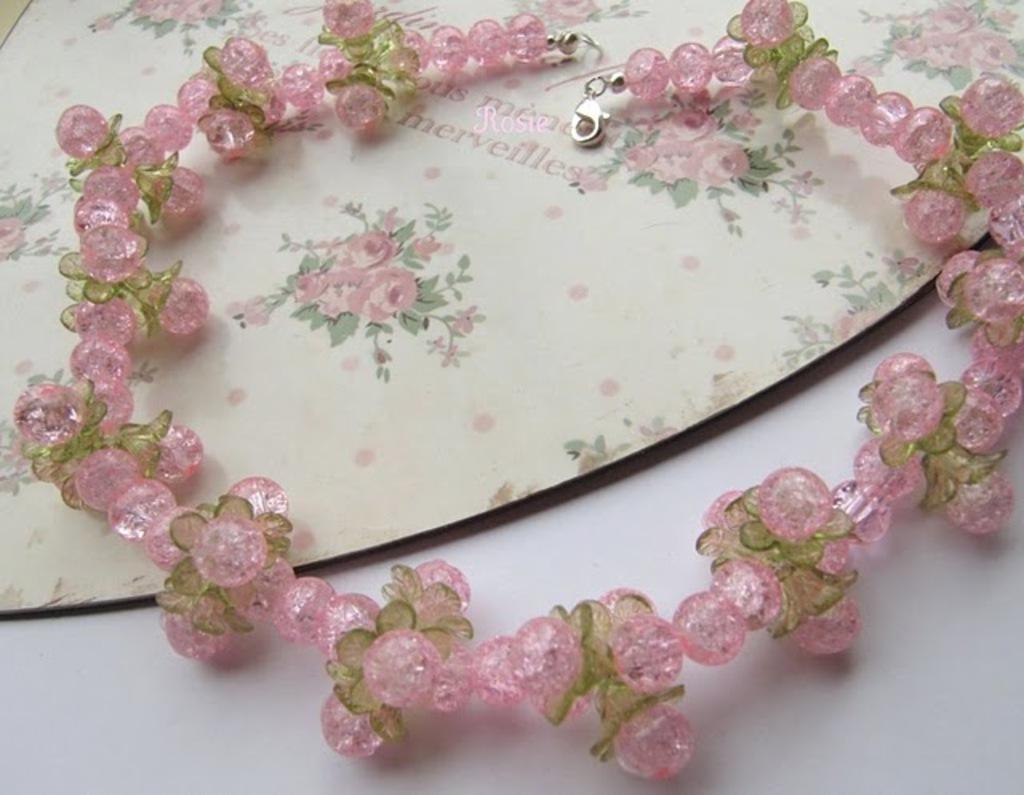How would you summarize this image in a sentence or two? The picture consists of a chain or necklace. At the bottom there is white surface. 